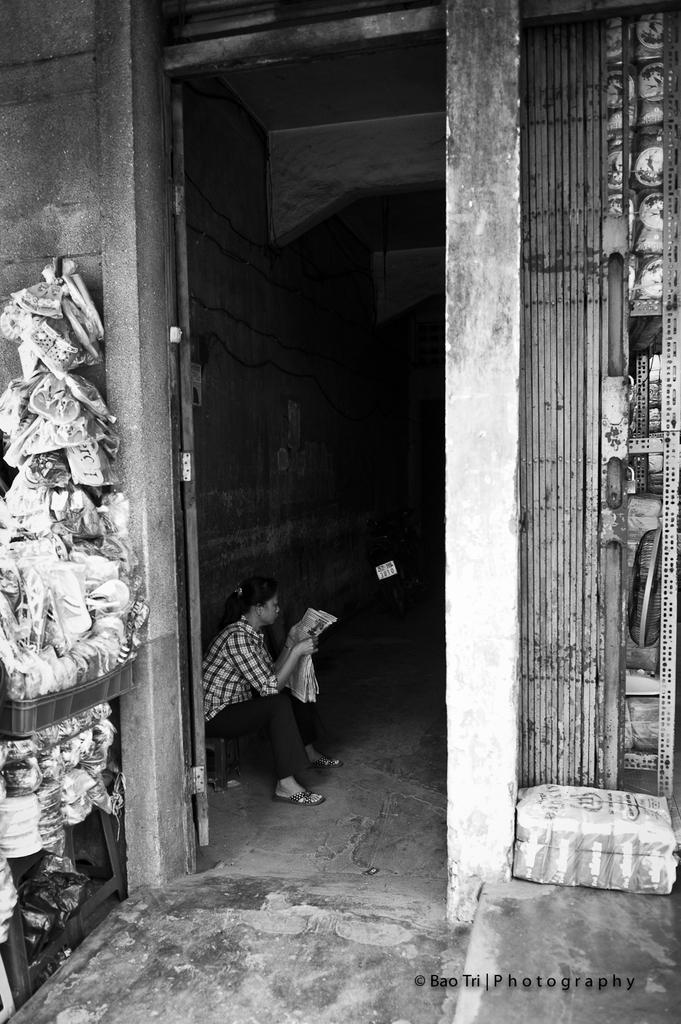Describe this image in one or two sentences. This is a black and white picture. A woman is sitting on a stool and she is holding a paper in her hand. Left side there are few objects on the table. Right side there is a rack having few objects on it. Middle of image there is a bike. 